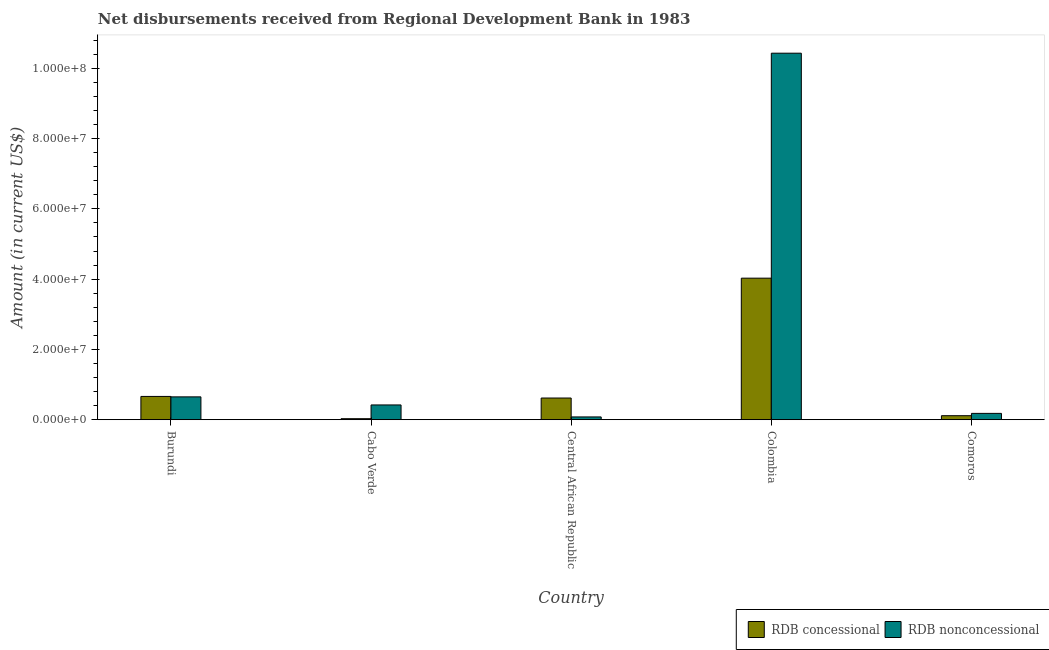How many groups of bars are there?
Ensure brevity in your answer.  5. Are the number of bars on each tick of the X-axis equal?
Give a very brief answer. Yes. What is the label of the 1st group of bars from the left?
Your answer should be very brief. Burundi. In how many cases, is the number of bars for a given country not equal to the number of legend labels?
Ensure brevity in your answer.  0. What is the net concessional disbursements from rdb in Cabo Verde?
Ensure brevity in your answer.  2.84e+05. Across all countries, what is the maximum net non concessional disbursements from rdb?
Provide a succinct answer. 1.04e+08. Across all countries, what is the minimum net non concessional disbursements from rdb?
Your response must be concise. 7.88e+05. In which country was the net concessional disbursements from rdb minimum?
Your answer should be compact. Cabo Verde. What is the total net concessional disbursements from rdb in the graph?
Make the answer very short. 5.45e+07. What is the difference between the net non concessional disbursements from rdb in Colombia and that in Comoros?
Ensure brevity in your answer.  1.02e+08. What is the difference between the net non concessional disbursements from rdb in Central African Republic and the net concessional disbursements from rdb in Colombia?
Your answer should be compact. -3.95e+07. What is the average net concessional disbursements from rdb per country?
Give a very brief answer. 1.09e+07. What is the difference between the net non concessional disbursements from rdb and net concessional disbursements from rdb in Colombia?
Ensure brevity in your answer.  6.40e+07. In how many countries, is the net concessional disbursements from rdb greater than 100000000 US$?
Your response must be concise. 0. What is the ratio of the net non concessional disbursements from rdb in Burundi to that in Comoros?
Your answer should be compact. 3.62. Is the net concessional disbursements from rdb in Cabo Verde less than that in Central African Republic?
Your response must be concise. Yes. What is the difference between the highest and the second highest net concessional disbursements from rdb?
Your response must be concise. 3.37e+07. What is the difference between the highest and the lowest net concessional disbursements from rdb?
Offer a terse response. 4.00e+07. In how many countries, is the net non concessional disbursements from rdb greater than the average net non concessional disbursements from rdb taken over all countries?
Make the answer very short. 1. What does the 2nd bar from the left in Colombia represents?
Make the answer very short. RDB nonconcessional. What does the 2nd bar from the right in Burundi represents?
Ensure brevity in your answer.  RDB concessional. How many bars are there?
Keep it short and to the point. 10. How many countries are there in the graph?
Provide a succinct answer. 5. What is the difference between two consecutive major ticks on the Y-axis?
Provide a succinct answer. 2.00e+07. Where does the legend appear in the graph?
Give a very brief answer. Bottom right. What is the title of the graph?
Keep it short and to the point. Net disbursements received from Regional Development Bank in 1983. Does "Savings" appear as one of the legend labels in the graph?
Make the answer very short. No. What is the label or title of the X-axis?
Your answer should be very brief. Country. What is the Amount (in current US$) of RDB concessional in Burundi?
Your answer should be compact. 6.62e+06. What is the Amount (in current US$) in RDB nonconcessional in Burundi?
Your answer should be very brief. 6.50e+06. What is the Amount (in current US$) in RDB concessional in Cabo Verde?
Give a very brief answer. 2.84e+05. What is the Amount (in current US$) in RDB nonconcessional in Cabo Verde?
Give a very brief answer. 4.20e+06. What is the Amount (in current US$) of RDB concessional in Central African Republic?
Provide a succinct answer. 6.17e+06. What is the Amount (in current US$) of RDB nonconcessional in Central African Republic?
Give a very brief answer. 7.88e+05. What is the Amount (in current US$) of RDB concessional in Colombia?
Provide a short and direct response. 4.03e+07. What is the Amount (in current US$) in RDB nonconcessional in Colombia?
Provide a succinct answer. 1.04e+08. What is the Amount (in current US$) in RDB concessional in Comoros?
Offer a very short reply. 1.14e+06. What is the Amount (in current US$) in RDB nonconcessional in Comoros?
Ensure brevity in your answer.  1.80e+06. Across all countries, what is the maximum Amount (in current US$) in RDB concessional?
Offer a very short reply. 4.03e+07. Across all countries, what is the maximum Amount (in current US$) of RDB nonconcessional?
Offer a very short reply. 1.04e+08. Across all countries, what is the minimum Amount (in current US$) in RDB concessional?
Offer a very short reply. 2.84e+05. Across all countries, what is the minimum Amount (in current US$) in RDB nonconcessional?
Provide a short and direct response. 7.88e+05. What is the total Amount (in current US$) of RDB concessional in the graph?
Your answer should be compact. 5.45e+07. What is the total Amount (in current US$) of RDB nonconcessional in the graph?
Your response must be concise. 1.18e+08. What is the difference between the Amount (in current US$) of RDB concessional in Burundi and that in Cabo Verde?
Your answer should be compact. 6.34e+06. What is the difference between the Amount (in current US$) in RDB nonconcessional in Burundi and that in Cabo Verde?
Give a very brief answer. 2.30e+06. What is the difference between the Amount (in current US$) in RDB concessional in Burundi and that in Central African Republic?
Offer a very short reply. 4.52e+05. What is the difference between the Amount (in current US$) of RDB nonconcessional in Burundi and that in Central African Republic?
Give a very brief answer. 5.71e+06. What is the difference between the Amount (in current US$) of RDB concessional in Burundi and that in Colombia?
Offer a very short reply. -3.37e+07. What is the difference between the Amount (in current US$) of RDB nonconcessional in Burundi and that in Colombia?
Offer a terse response. -9.78e+07. What is the difference between the Amount (in current US$) in RDB concessional in Burundi and that in Comoros?
Give a very brief answer. 5.48e+06. What is the difference between the Amount (in current US$) of RDB nonconcessional in Burundi and that in Comoros?
Make the answer very short. 4.70e+06. What is the difference between the Amount (in current US$) of RDB concessional in Cabo Verde and that in Central African Republic?
Provide a succinct answer. -5.88e+06. What is the difference between the Amount (in current US$) of RDB nonconcessional in Cabo Verde and that in Central African Republic?
Make the answer very short. 3.41e+06. What is the difference between the Amount (in current US$) in RDB concessional in Cabo Verde and that in Colombia?
Make the answer very short. -4.00e+07. What is the difference between the Amount (in current US$) of RDB nonconcessional in Cabo Verde and that in Colombia?
Offer a terse response. -1.00e+08. What is the difference between the Amount (in current US$) in RDB concessional in Cabo Verde and that in Comoros?
Ensure brevity in your answer.  -8.57e+05. What is the difference between the Amount (in current US$) of RDB nonconcessional in Cabo Verde and that in Comoros?
Your response must be concise. 2.40e+06. What is the difference between the Amount (in current US$) in RDB concessional in Central African Republic and that in Colombia?
Make the answer very short. -3.41e+07. What is the difference between the Amount (in current US$) of RDB nonconcessional in Central African Republic and that in Colombia?
Make the answer very short. -1.03e+08. What is the difference between the Amount (in current US$) of RDB concessional in Central African Republic and that in Comoros?
Offer a terse response. 5.03e+06. What is the difference between the Amount (in current US$) of RDB nonconcessional in Central African Republic and that in Comoros?
Make the answer very short. -1.01e+06. What is the difference between the Amount (in current US$) of RDB concessional in Colombia and that in Comoros?
Ensure brevity in your answer.  3.91e+07. What is the difference between the Amount (in current US$) in RDB nonconcessional in Colombia and that in Comoros?
Ensure brevity in your answer.  1.02e+08. What is the difference between the Amount (in current US$) of RDB concessional in Burundi and the Amount (in current US$) of RDB nonconcessional in Cabo Verde?
Your response must be concise. 2.42e+06. What is the difference between the Amount (in current US$) of RDB concessional in Burundi and the Amount (in current US$) of RDB nonconcessional in Central African Republic?
Your answer should be compact. 5.83e+06. What is the difference between the Amount (in current US$) of RDB concessional in Burundi and the Amount (in current US$) of RDB nonconcessional in Colombia?
Keep it short and to the point. -9.77e+07. What is the difference between the Amount (in current US$) in RDB concessional in Burundi and the Amount (in current US$) in RDB nonconcessional in Comoros?
Ensure brevity in your answer.  4.82e+06. What is the difference between the Amount (in current US$) in RDB concessional in Cabo Verde and the Amount (in current US$) in RDB nonconcessional in Central African Republic?
Keep it short and to the point. -5.04e+05. What is the difference between the Amount (in current US$) in RDB concessional in Cabo Verde and the Amount (in current US$) in RDB nonconcessional in Colombia?
Offer a terse response. -1.04e+08. What is the difference between the Amount (in current US$) of RDB concessional in Cabo Verde and the Amount (in current US$) of RDB nonconcessional in Comoros?
Offer a very short reply. -1.51e+06. What is the difference between the Amount (in current US$) of RDB concessional in Central African Republic and the Amount (in current US$) of RDB nonconcessional in Colombia?
Your answer should be very brief. -9.81e+07. What is the difference between the Amount (in current US$) of RDB concessional in Central African Republic and the Amount (in current US$) of RDB nonconcessional in Comoros?
Ensure brevity in your answer.  4.37e+06. What is the difference between the Amount (in current US$) of RDB concessional in Colombia and the Amount (in current US$) of RDB nonconcessional in Comoros?
Offer a very short reply. 3.85e+07. What is the average Amount (in current US$) in RDB concessional per country?
Provide a succinct answer. 1.09e+07. What is the average Amount (in current US$) in RDB nonconcessional per country?
Offer a terse response. 2.35e+07. What is the difference between the Amount (in current US$) of RDB concessional and Amount (in current US$) of RDB nonconcessional in Burundi?
Your answer should be compact. 1.24e+05. What is the difference between the Amount (in current US$) of RDB concessional and Amount (in current US$) of RDB nonconcessional in Cabo Verde?
Provide a succinct answer. -3.92e+06. What is the difference between the Amount (in current US$) of RDB concessional and Amount (in current US$) of RDB nonconcessional in Central African Republic?
Offer a very short reply. 5.38e+06. What is the difference between the Amount (in current US$) of RDB concessional and Amount (in current US$) of RDB nonconcessional in Colombia?
Ensure brevity in your answer.  -6.40e+07. What is the difference between the Amount (in current US$) in RDB concessional and Amount (in current US$) in RDB nonconcessional in Comoros?
Provide a short and direct response. -6.56e+05. What is the ratio of the Amount (in current US$) in RDB concessional in Burundi to that in Cabo Verde?
Give a very brief answer. 23.31. What is the ratio of the Amount (in current US$) of RDB nonconcessional in Burundi to that in Cabo Verde?
Give a very brief answer. 1.55. What is the ratio of the Amount (in current US$) of RDB concessional in Burundi to that in Central African Republic?
Your response must be concise. 1.07. What is the ratio of the Amount (in current US$) in RDB nonconcessional in Burundi to that in Central African Republic?
Your answer should be compact. 8.24. What is the ratio of the Amount (in current US$) of RDB concessional in Burundi to that in Colombia?
Your answer should be very brief. 0.16. What is the ratio of the Amount (in current US$) in RDB nonconcessional in Burundi to that in Colombia?
Keep it short and to the point. 0.06. What is the ratio of the Amount (in current US$) of RDB concessional in Burundi to that in Comoros?
Make the answer very short. 5.8. What is the ratio of the Amount (in current US$) of RDB nonconcessional in Burundi to that in Comoros?
Keep it short and to the point. 3.62. What is the ratio of the Amount (in current US$) in RDB concessional in Cabo Verde to that in Central African Republic?
Your answer should be very brief. 0.05. What is the ratio of the Amount (in current US$) of RDB nonconcessional in Cabo Verde to that in Central African Republic?
Offer a very short reply. 5.33. What is the ratio of the Amount (in current US$) in RDB concessional in Cabo Verde to that in Colombia?
Ensure brevity in your answer.  0.01. What is the ratio of the Amount (in current US$) in RDB nonconcessional in Cabo Verde to that in Colombia?
Your answer should be very brief. 0.04. What is the ratio of the Amount (in current US$) of RDB concessional in Cabo Verde to that in Comoros?
Your answer should be compact. 0.25. What is the ratio of the Amount (in current US$) in RDB nonconcessional in Cabo Verde to that in Comoros?
Your response must be concise. 2.34. What is the ratio of the Amount (in current US$) of RDB concessional in Central African Republic to that in Colombia?
Your answer should be very brief. 0.15. What is the ratio of the Amount (in current US$) in RDB nonconcessional in Central African Republic to that in Colombia?
Your response must be concise. 0.01. What is the ratio of the Amount (in current US$) of RDB concessional in Central African Republic to that in Comoros?
Provide a short and direct response. 5.41. What is the ratio of the Amount (in current US$) in RDB nonconcessional in Central African Republic to that in Comoros?
Provide a succinct answer. 0.44. What is the ratio of the Amount (in current US$) of RDB concessional in Colombia to that in Comoros?
Your answer should be compact. 35.3. What is the ratio of the Amount (in current US$) of RDB nonconcessional in Colombia to that in Comoros?
Your response must be concise. 58.03. What is the difference between the highest and the second highest Amount (in current US$) of RDB concessional?
Offer a terse response. 3.37e+07. What is the difference between the highest and the second highest Amount (in current US$) in RDB nonconcessional?
Keep it short and to the point. 9.78e+07. What is the difference between the highest and the lowest Amount (in current US$) of RDB concessional?
Your answer should be very brief. 4.00e+07. What is the difference between the highest and the lowest Amount (in current US$) in RDB nonconcessional?
Your answer should be very brief. 1.03e+08. 